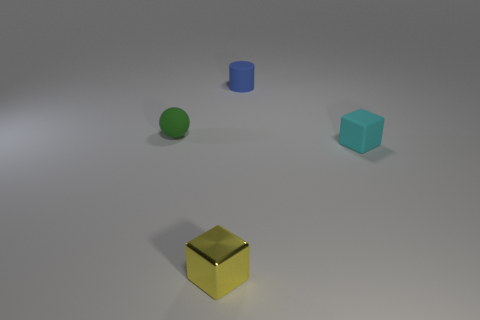How many blue cylinders are the same material as the green ball?
Your answer should be compact. 1. Do the green sphere and the cyan rubber cube have the same size?
Offer a very short reply. Yes. Are there any other things that have the same color as the tiny metal object?
Your answer should be very brief. No. What shape is the tiny thing that is on the left side of the tiny blue cylinder and on the right side of the green thing?
Offer a very short reply. Cube. What is the size of the thing that is in front of the small cyan block?
Offer a very short reply. Small. There is a tiny rubber thing behind the small object on the left side of the small shiny block; what number of green things are in front of it?
Your answer should be compact. 1. Are there any small rubber objects right of the matte cylinder?
Your response must be concise. Yes. How many other objects are the same size as the matte sphere?
Provide a succinct answer. 3. What material is the tiny thing that is both on the left side of the tiny blue cylinder and in front of the sphere?
Your response must be concise. Metal. Is the shape of the tiny object that is in front of the small cyan block the same as the matte thing to the right of the blue thing?
Provide a short and direct response. Yes. 